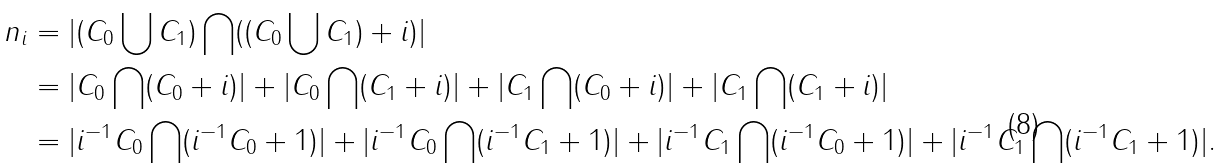<formula> <loc_0><loc_0><loc_500><loc_500>n _ { i } & = | ( C _ { 0 } \bigcup C _ { 1 } ) \bigcap ( ( C _ { 0 } \bigcup C _ { 1 } ) + i ) | \\ & = | C _ { 0 } \bigcap ( C _ { 0 } + i ) | + | C _ { 0 } \bigcap ( C _ { 1 } + i ) | + | C _ { 1 } \bigcap ( C _ { 0 } + i ) | + | C _ { 1 } \bigcap ( C _ { 1 } + i ) | \\ & = | i ^ { - 1 } C _ { 0 } \bigcap ( i ^ { - 1 } C _ { 0 } + 1 ) | + | i ^ { - 1 } C _ { 0 } \bigcap ( i ^ { - 1 } C _ { 1 } + 1 ) | + | i ^ { - 1 } C _ { 1 } \bigcap ( i ^ { - 1 } C _ { 0 } + 1 ) | + | i ^ { - 1 } C _ { 1 } \bigcap ( i ^ { - 1 } C _ { 1 } + 1 ) | .</formula> 